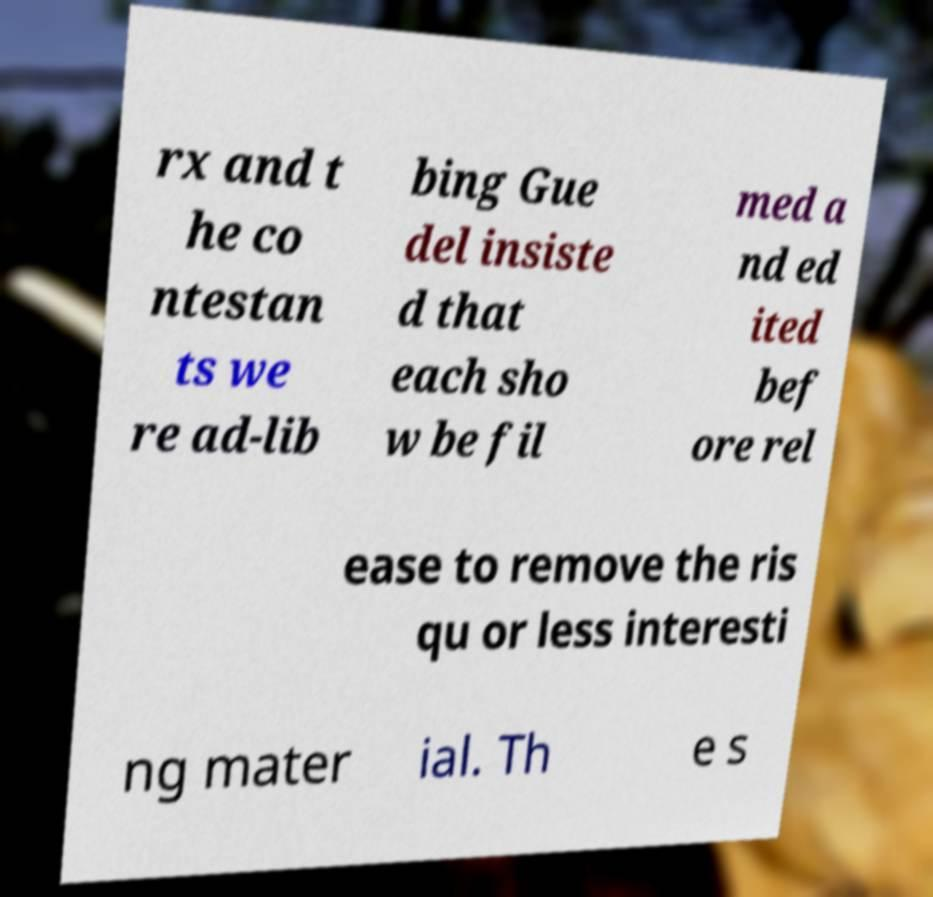I need the written content from this picture converted into text. Can you do that? rx and t he co ntestan ts we re ad-lib bing Gue del insiste d that each sho w be fil med a nd ed ited bef ore rel ease to remove the ris qu or less interesti ng mater ial. Th e s 